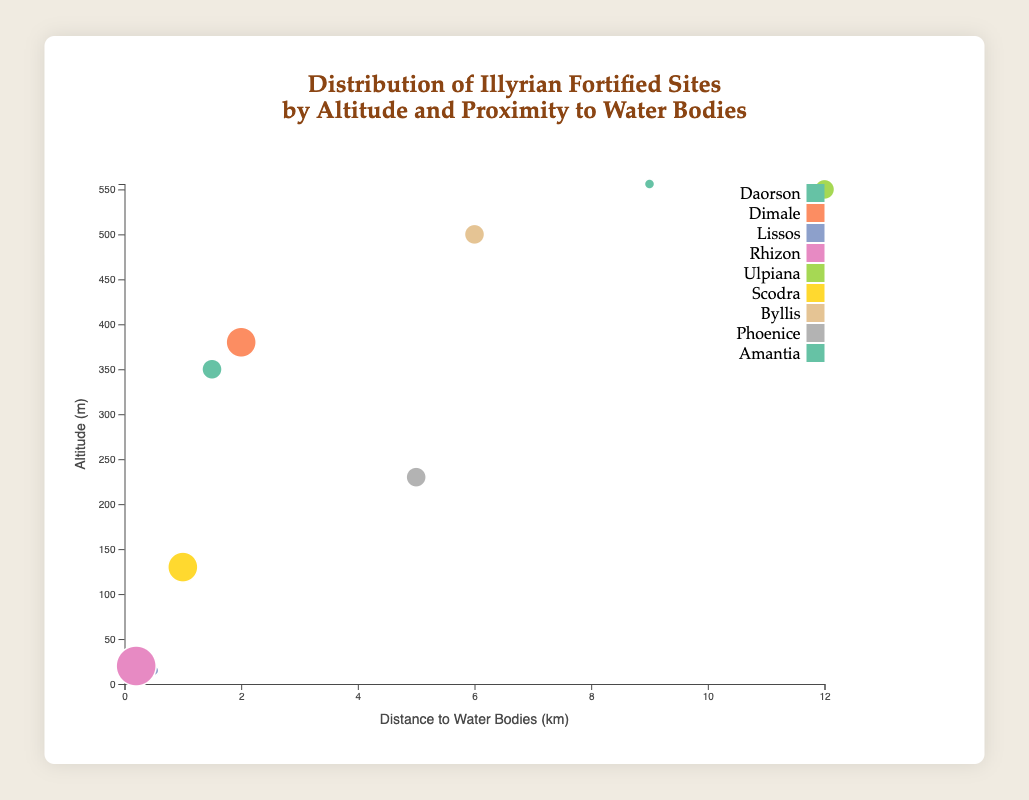Which site is at the highest altitude? By looking at the y-axis (Altitude), Amantia is the site located at the highest point, at 556 meters.
Answer: Amantia Which site is closest to a water body? By looking at the x-axis (Distance to Water Bodies), Rhizon has the smallest distance to a water body at 0.2 km.
Answer: Rhizon How many sites have an importance level of 3? The bubble sizes indicate importance levels. On inspection, Daorson, Ulpiana, Byllis, and Phoenice all have similar medium-sized bubbles corresponding to an importance level of 3, so there are 4 sites.
Answer: 4 Which site is both at high altitude and far from water bodies? Combining information from the x-axis (Distance to Water Bodies) and y-axis (Altitude), Ulpiana is at 550 meters and 12 km away from water bodies.
Answer: Ulpiana Which sites are more important, Lissos or Scodra? By comparing bubble sizes, Scodra has a larger bubble (importance 4) compared to Lissos (importance 2).
Answer: Scodra What’s the combined importance level of all sites? Sum up the importance levels: 3 + 4 + 2 + 5 + 3 + 4 + 3 + 3 + 2 = 29
Answer: 29 How does the altitude of Byllis compare to Daorson? Byllis is at 500 meters and Daorson is at 350 meters, so Byllis is higher.
Answer: Byllis What’s the difference in altitude between the highest and lowest sites? The highest altitude is Amantia at 556 meters and the lowest is Lissos at 15 meters. The difference is 556 - 15 = 541 meters.
Answer: 541 meters Which site is farthest from water but has a medium importance level? Ulpiana is 12 km from water and has an importance level of 3 (medium).
Answer: Ulpiana What’s the average altitude of sites with an importance level of 3? The sites are Daorson (350m), Ulpiana (550m), Byllis (500m), and Phoenice (230m). Average altitude is (350 + 550 + 500 + 230) / 4 = 1630 / 4 = 407.5 meters.
Answer: 407.5 meters 